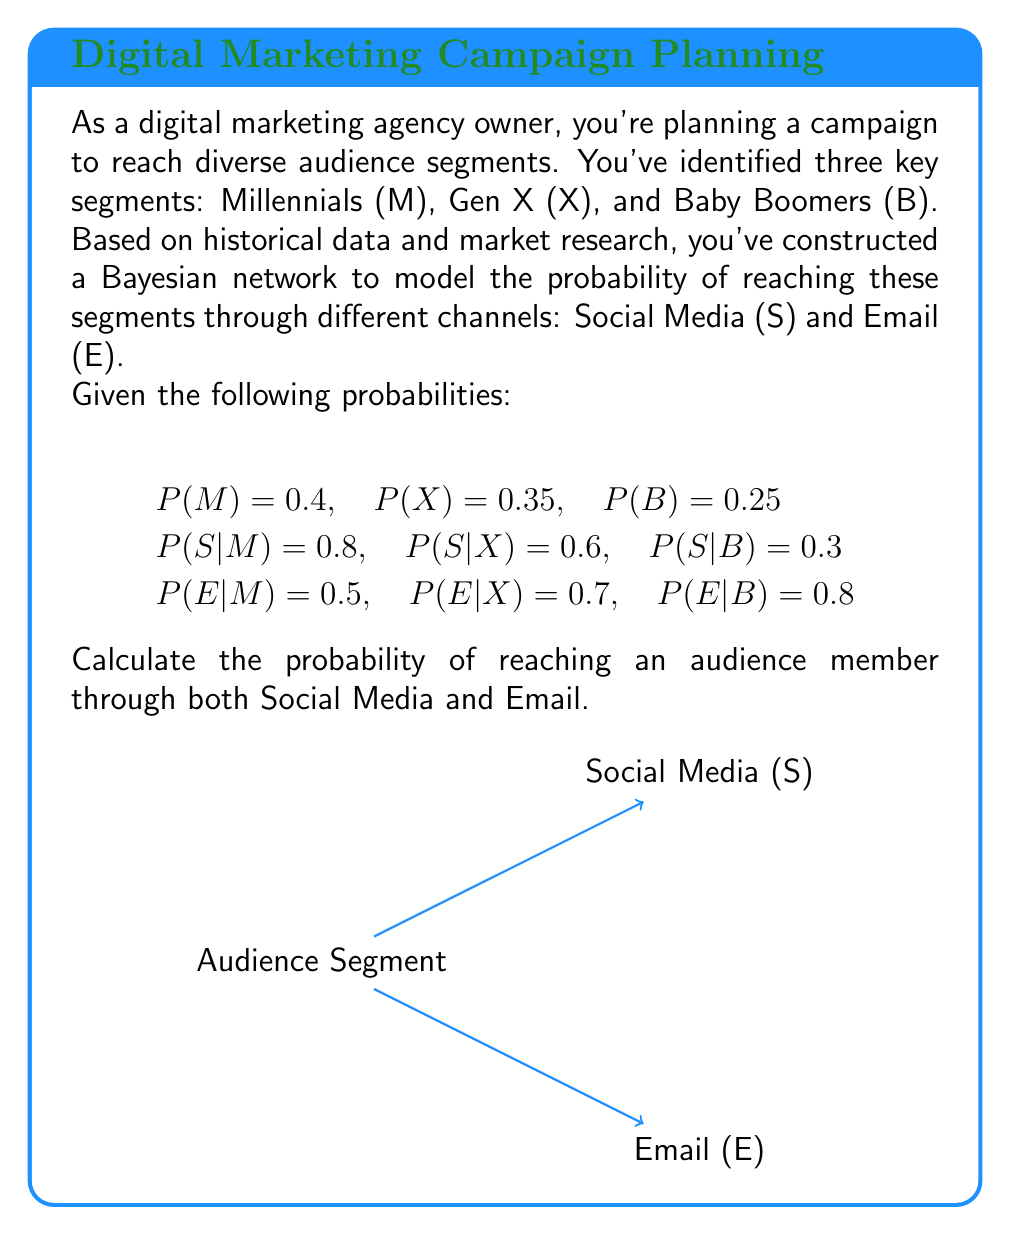Help me with this question. To solve this problem, we'll use the law of total probability and the multiplication rule of probability. We need to calculate P(S ∩ E) for all audience segments.

Step 1: Calculate P(S ∩ E) for each segment
For Millennials:
P(S ∩ E|M) = P(S|M) × P(E|M) = 0.8 × 0.5 = 0.4

For Gen X:
P(S ∩ E|X) = P(S|X) × P(E|X) = 0.6 × 0.7 = 0.42

For Baby Boomers:
P(S ∩ E|B) = P(S|B) × P(E|B) = 0.3 × 0.8 = 0.24

Step 2: Apply the law of total probability
P(S ∩ E) = P(S ∩ E|M) × P(M) + P(S ∩ E|X) × P(X) + P(S ∩ E|B) × P(B)

Step 3: Substitute the values
P(S ∩ E) = 0.4 × 0.4 + 0.42 × 0.35 + 0.24 × 0.25

Step 4: Calculate the final probability
P(S ∩ E) = 0.16 + 0.147 + 0.06 = 0.367

Therefore, the probability of reaching an audience member through both Social Media and Email is 0.367 or 36.7%.
Answer: 0.367 